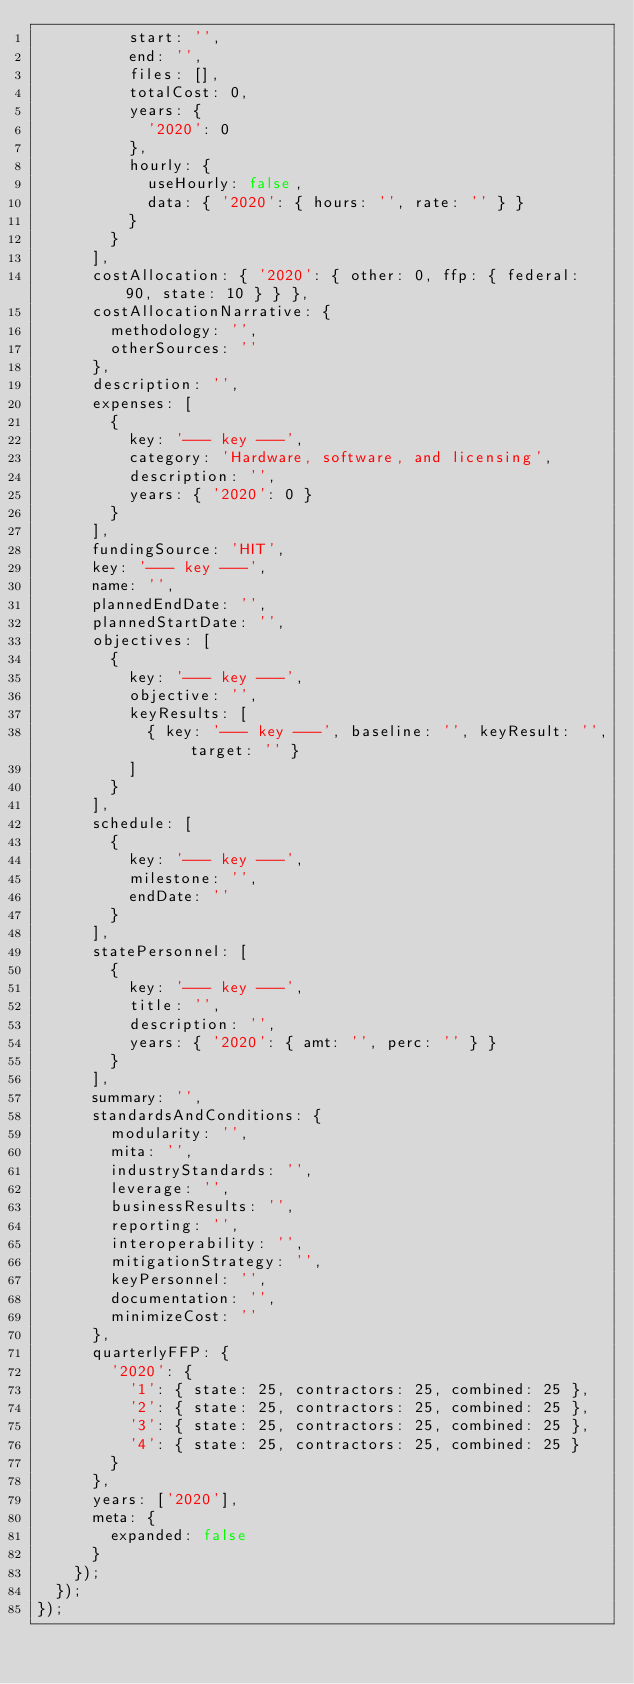Convert code to text. <code><loc_0><loc_0><loc_500><loc_500><_JavaScript_>          start: '',
          end: '',
          files: [],
          totalCost: 0,
          years: {
            '2020': 0
          },
          hourly: {
            useHourly: false,
            data: { '2020': { hours: '', rate: '' } }
          }
        }
      ],
      costAllocation: { '2020': { other: 0, ffp: { federal: 90, state: 10 } } },
      costAllocationNarrative: {
        methodology: '',
        otherSources: ''
      },
      description: '',
      expenses: [
        {
          key: '--- key ---',
          category: 'Hardware, software, and licensing',
          description: '',
          years: { '2020': 0 }
        }
      ],
      fundingSource: 'HIT',
      key: '--- key ---',
      name: '',
      plannedEndDate: '',
      plannedStartDate: '',
      objectives: [
        {
          key: '--- key ---',
          objective: '',
          keyResults: [
            { key: '--- key ---', baseline: '', keyResult: '', target: '' }
          ]
        }
      ],
      schedule: [
        {
          key: '--- key ---',
          milestone: '',
          endDate: ''
        }
      ],
      statePersonnel: [
        {
          key: '--- key ---',
          title: '',
          description: '',
          years: { '2020': { amt: '', perc: '' } }
        }
      ],
      summary: '',
      standardsAndConditions: {
        modularity: '',
        mita: '',
        industryStandards: '',
        leverage: '',
        businessResults: '',
        reporting: '',
        interoperability: '',
        mitigationStrategy: '',
        keyPersonnel: '',
        documentation: '',
        minimizeCost: ''
      },
      quarterlyFFP: {
        '2020': {
          '1': { state: 25, contractors: 25, combined: 25 },
          '2': { state: 25, contractors: 25, combined: 25 },
          '3': { state: 25, contractors: 25, combined: 25 },
          '4': { state: 25, contractors: 25, combined: 25 }
        }
      },
      years: ['2020'],
      meta: {
        expanded: false
      }
    });
  });
});
</code> 